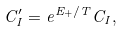Convert formula to latex. <formula><loc_0><loc_0><loc_500><loc_500>C _ { I } ^ { \prime } = e ^ { E _ { + } / T } C _ { I } ,</formula> 